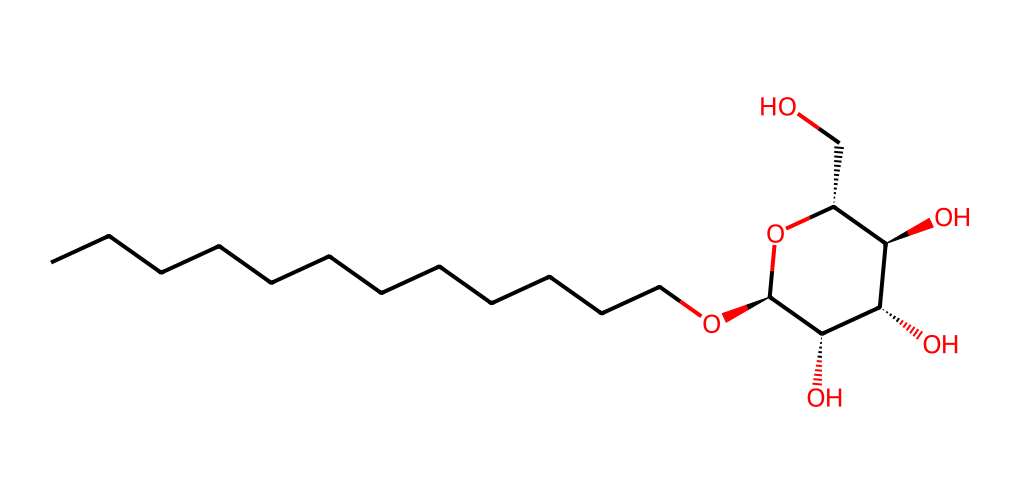How many carbon atoms are in this structure? By analyzing the provided SMILES representation, we can count the number of carbon (C) atoms by observing each segment and recognizing the straight-chain and cyclic parts. The main chain has 12 carbon atoms, with additional carbons in the cyclic structure, for a total of 13 carbon atoms.
Answer: 13 What is the functional group present in this molecule? This SMILES representation shows an ether linkage, indicated by the presence of the 'O' between carbon chains (CCCCCCCCCCCCO). Additionally, there are hydroxyl (-OH) groups visible in the cyclic part of the molecule, further confirming the presence of alcohol functional groups.
Answer: ether and alcohol Is this molecule hydrophilic or hydrophobic? The structure contains a long hydrophobic carbon chain (which makes it hydrophobic) and multiple hydroxyl groups (which are hydrophilic). The presence of both components suggests that it has amphiphilic properties, allowing it to interact with both water and oils.
Answer: amphiphilic How many hydroxyl groups are in this molecule? From the structure, we can identify the hydroxyl groups (−OH) that are part of the carbohydrate structure. There are four –OH groups present, indicating that this molecule has a significant ability to interact with water.
Answer: four What type of surfactant can be derived from this molecule? Given the structure's long hydrophobic tail and polar head (due to the hydroxyl groups), this molecule can act as a non-ionic surfactant. Non-ionic surfactants are typically milder and less irritating, aligning well with sustainable cleaning solutions derived from crop by-products.
Answer: non-ionic surfactant 